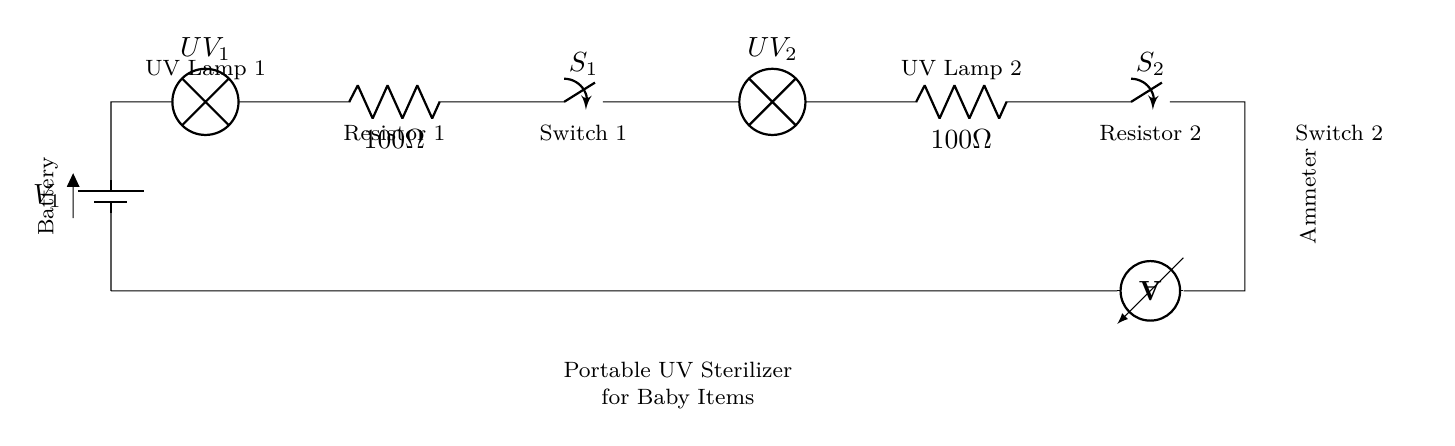what is the type of this circuit? The circuit is a series circuit because all components are connected end-to-end in a single path, which means that the current flows through each component sequentially.
Answer: series circuit what does the battery provide? The battery provides the voltage, which is the necessary potential difference to drive current through the circuit.
Answer: voltage how many UV lamps are in this circuit? There are two UV lamps shown in the circuit, labeled as UV lamp 1 and UV lamp 2.
Answer: two what is the resistance of Resistor 1? Resistor 1 has a resistance of 100 Ohms as indicated beside it in the circuit diagram.
Answer: 100 Ohm which component controls the flow of current to UV lamp 1? Switch 1 controls the flow of current to UV lamp 1, as it is positioned in series between the battery and UV lamp 1.
Answer: Switch 1 if both switches are closed, will the ammeter register any current? Yes, if both switches are closed, the circuit will be complete, and current will flow through the ammeter, allowing it to register the current.
Answer: Yes what happens if Resistor 2 is removed? If Resistor 2 is removed, the circuit would become unbalanced, potentially causing excessive current through UV lamp 2, which could damage the lamp.
Answer: Unbalanced circuit 